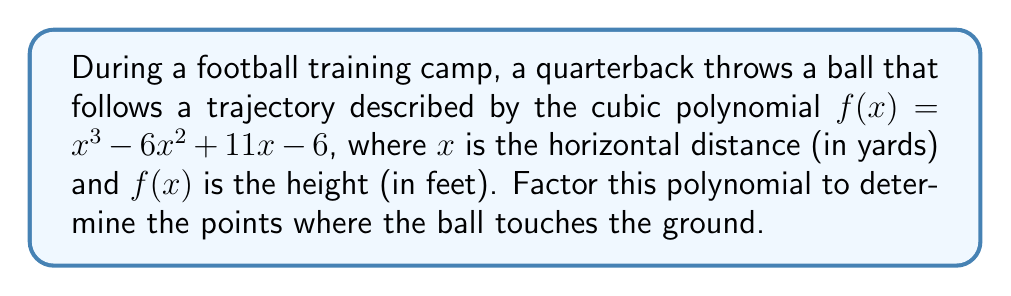Can you answer this question? Let's approach this step-by-step:

1) First, we need to recognize that the points where the ball touches the ground are the roots of the polynomial. At these points, $f(x) = 0$.

2) For a cubic polynomial $ax^3 + bx^2 + cx + d$, if it can be factored, one factor will be $(x - r)$, where $r$ is a root of the polynomial.

3) To find a potential root, we can use the rational root theorem. The possible rational roots are the factors of the constant term (6 in this case): $\pm1, \pm2, \pm3, \pm6$.

4) Let's try $x = 1$:
   $f(1) = 1^3 - 6(1)^2 + 11(1) - 6 = 1 - 6 + 11 - 6 = 0$

5) So, $(x - 1)$ is a factor. We can use polynomial long division to find the other factor:

   $$\frac{x^3 - 6x^2 + 11x - 6}{x - 1} = x^2 - 5x + 6$$

6) Now our polynomial is: $f(x) = (x - 1)(x^2 - 5x + 6)$

7) We can factor the quadratic term further:
   $x^2 - 5x + 6 = (x - 2)(x - 3)$

8) Therefore, the fully factored polynomial is:
   $f(x) = (x - 1)(x - 2)(x - 3)$

The roots of this polynomial, which represent the points where the ball touches the ground, are $x = 1$, $x = 2$, and $x = 3$.
Answer: $f(x) = (x - 1)(x - 2)(x - 3)$ 